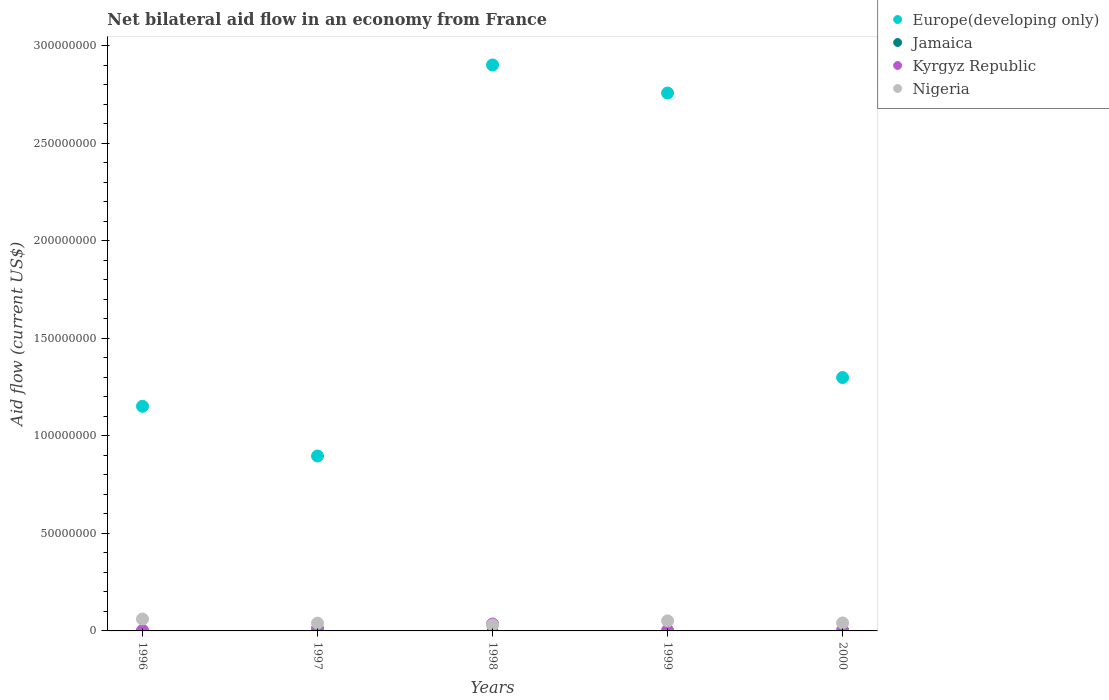Is the number of dotlines equal to the number of legend labels?
Provide a succinct answer. No. What is the net bilateral aid flow in Europe(developing only) in 1999?
Keep it short and to the point. 2.76e+08. Across all years, what is the maximum net bilateral aid flow in Nigeria?
Offer a very short reply. 6.08e+06. Across all years, what is the minimum net bilateral aid flow in Kyrgyz Republic?
Offer a terse response. 2.50e+05. What is the total net bilateral aid flow in Europe(developing only) in the graph?
Your answer should be compact. 9.01e+08. What is the difference between the net bilateral aid flow in Kyrgyz Republic in 1998 and that in 1999?
Your answer should be compact. 3.26e+06. What is the difference between the net bilateral aid flow in Kyrgyz Republic in 1997 and the net bilateral aid flow in Nigeria in 2000?
Provide a short and direct response. -2.86e+06. What is the average net bilateral aid flow in Europe(developing only) per year?
Keep it short and to the point. 1.80e+08. In the year 1996, what is the difference between the net bilateral aid flow in Nigeria and net bilateral aid flow in Europe(developing only)?
Provide a succinct answer. -1.09e+08. In how many years, is the net bilateral aid flow in Nigeria greater than 180000000 US$?
Your response must be concise. 0. What is the ratio of the net bilateral aid flow in Nigeria in 1996 to that in 2000?
Make the answer very short. 1.48. Is the difference between the net bilateral aid flow in Nigeria in 1997 and 1999 greater than the difference between the net bilateral aid flow in Europe(developing only) in 1997 and 1999?
Keep it short and to the point. Yes. What is the difference between the highest and the second highest net bilateral aid flow in Europe(developing only)?
Provide a succinct answer. 1.44e+07. What is the difference between the highest and the lowest net bilateral aid flow in Europe(developing only)?
Your answer should be very brief. 2.01e+08. Is the sum of the net bilateral aid flow in Kyrgyz Republic in 1999 and 2000 greater than the maximum net bilateral aid flow in Nigeria across all years?
Give a very brief answer. No. How many years are there in the graph?
Your answer should be very brief. 5. Does the graph contain grids?
Your response must be concise. No. Where does the legend appear in the graph?
Provide a short and direct response. Top right. How many legend labels are there?
Keep it short and to the point. 4. How are the legend labels stacked?
Your response must be concise. Vertical. What is the title of the graph?
Ensure brevity in your answer.  Net bilateral aid flow in an economy from France. What is the label or title of the Y-axis?
Provide a short and direct response. Aid flow (current US$). What is the Aid flow (current US$) in Europe(developing only) in 1996?
Your answer should be very brief. 1.15e+08. What is the Aid flow (current US$) in Jamaica in 1996?
Make the answer very short. 0. What is the Aid flow (current US$) of Kyrgyz Republic in 1996?
Make the answer very short. 2.50e+05. What is the Aid flow (current US$) of Nigeria in 1996?
Offer a terse response. 6.08e+06. What is the Aid flow (current US$) in Europe(developing only) in 1997?
Your answer should be compact. 8.97e+07. What is the Aid flow (current US$) of Jamaica in 1997?
Give a very brief answer. 0. What is the Aid flow (current US$) in Kyrgyz Republic in 1997?
Keep it short and to the point. 1.24e+06. What is the Aid flow (current US$) in Nigeria in 1997?
Your answer should be very brief. 3.98e+06. What is the Aid flow (current US$) in Europe(developing only) in 1998?
Ensure brevity in your answer.  2.90e+08. What is the Aid flow (current US$) of Jamaica in 1998?
Your answer should be compact. 0. What is the Aid flow (current US$) of Kyrgyz Republic in 1998?
Offer a terse response. 3.55e+06. What is the Aid flow (current US$) in Nigeria in 1998?
Offer a terse response. 3.04e+06. What is the Aid flow (current US$) in Europe(developing only) in 1999?
Your answer should be very brief. 2.76e+08. What is the Aid flow (current US$) of Jamaica in 1999?
Your answer should be very brief. 0. What is the Aid flow (current US$) in Kyrgyz Republic in 1999?
Offer a terse response. 2.90e+05. What is the Aid flow (current US$) in Nigeria in 1999?
Ensure brevity in your answer.  5.16e+06. What is the Aid flow (current US$) in Europe(developing only) in 2000?
Provide a succinct answer. 1.30e+08. What is the Aid flow (current US$) of Kyrgyz Republic in 2000?
Provide a short and direct response. 3.90e+05. What is the Aid flow (current US$) in Nigeria in 2000?
Provide a short and direct response. 4.10e+06. Across all years, what is the maximum Aid flow (current US$) of Europe(developing only)?
Provide a short and direct response. 2.90e+08. Across all years, what is the maximum Aid flow (current US$) of Kyrgyz Republic?
Make the answer very short. 3.55e+06. Across all years, what is the maximum Aid flow (current US$) of Nigeria?
Offer a terse response. 6.08e+06. Across all years, what is the minimum Aid flow (current US$) of Europe(developing only)?
Keep it short and to the point. 8.97e+07. Across all years, what is the minimum Aid flow (current US$) in Kyrgyz Republic?
Provide a short and direct response. 2.50e+05. Across all years, what is the minimum Aid flow (current US$) in Nigeria?
Offer a very short reply. 3.04e+06. What is the total Aid flow (current US$) of Europe(developing only) in the graph?
Provide a short and direct response. 9.01e+08. What is the total Aid flow (current US$) in Jamaica in the graph?
Offer a terse response. 0. What is the total Aid flow (current US$) in Kyrgyz Republic in the graph?
Offer a very short reply. 5.72e+06. What is the total Aid flow (current US$) of Nigeria in the graph?
Your answer should be compact. 2.24e+07. What is the difference between the Aid flow (current US$) in Europe(developing only) in 1996 and that in 1997?
Offer a very short reply. 2.55e+07. What is the difference between the Aid flow (current US$) in Kyrgyz Republic in 1996 and that in 1997?
Your response must be concise. -9.90e+05. What is the difference between the Aid flow (current US$) in Nigeria in 1996 and that in 1997?
Offer a terse response. 2.10e+06. What is the difference between the Aid flow (current US$) in Europe(developing only) in 1996 and that in 1998?
Offer a very short reply. -1.75e+08. What is the difference between the Aid flow (current US$) in Kyrgyz Republic in 1996 and that in 1998?
Provide a short and direct response. -3.30e+06. What is the difference between the Aid flow (current US$) in Nigeria in 1996 and that in 1998?
Keep it short and to the point. 3.04e+06. What is the difference between the Aid flow (current US$) of Europe(developing only) in 1996 and that in 1999?
Your answer should be very brief. -1.61e+08. What is the difference between the Aid flow (current US$) in Nigeria in 1996 and that in 1999?
Give a very brief answer. 9.20e+05. What is the difference between the Aid flow (current US$) in Europe(developing only) in 1996 and that in 2000?
Give a very brief answer. -1.47e+07. What is the difference between the Aid flow (current US$) of Kyrgyz Republic in 1996 and that in 2000?
Keep it short and to the point. -1.40e+05. What is the difference between the Aid flow (current US$) of Nigeria in 1996 and that in 2000?
Provide a short and direct response. 1.98e+06. What is the difference between the Aid flow (current US$) of Europe(developing only) in 1997 and that in 1998?
Keep it short and to the point. -2.01e+08. What is the difference between the Aid flow (current US$) in Kyrgyz Republic in 1997 and that in 1998?
Offer a terse response. -2.31e+06. What is the difference between the Aid flow (current US$) in Nigeria in 1997 and that in 1998?
Offer a very short reply. 9.40e+05. What is the difference between the Aid flow (current US$) of Europe(developing only) in 1997 and that in 1999?
Provide a short and direct response. -1.86e+08. What is the difference between the Aid flow (current US$) of Kyrgyz Republic in 1997 and that in 1999?
Keep it short and to the point. 9.50e+05. What is the difference between the Aid flow (current US$) in Nigeria in 1997 and that in 1999?
Your response must be concise. -1.18e+06. What is the difference between the Aid flow (current US$) of Europe(developing only) in 1997 and that in 2000?
Your answer should be very brief. -4.02e+07. What is the difference between the Aid flow (current US$) of Kyrgyz Republic in 1997 and that in 2000?
Your answer should be compact. 8.50e+05. What is the difference between the Aid flow (current US$) of Europe(developing only) in 1998 and that in 1999?
Your response must be concise. 1.44e+07. What is the difference between the Aid flow (current US$) of Kyrgyz Republic in 1998 and that in 1999?
Provide a short and direct response. 3.26e+06. What is the difference between the Aid flow (current US$) of Nigeria in 1998 and that in 1999?
Make the answer very short. -2.12e+06. What is the difference between the Aid flow (current US$) in Europe(developing only) in 1998 and that in 2000?
Your response must be concise. 1.60e+08. What is the difference between the Aid flow (current US$) in Kyrgyz Republic in 1998 and that in 2000?
Ensure brevity in your answer.  3.16e+06. What is the difference between the Aid flow (current US$) of Nigeria in 1998 and that in 2000?
Your answer should be compact. -1.06e+06. What is the difference between the Aid flow (current US$) in Europe(developing only) in 1999 and that in 2000?
Offer a terse response. 1.46e+08. What is the difference between the Aid flow (current US$) of Kyrgyz Republic in 1999 and that in 2000?
Make the answer very short. -1.00e+05. What is the difference between the Aid flow (current US$) in Nigeria in 1999 and that in 2000?
Your answer should be very brief. 1.06e+06. What is the difference between the Aid flow (current US$) of Europe(developing only) in 1996 and the Aid flow (current US$) of Kyrgyz Republic in 1997?
Keep it short and to the point. 1.14e+08. What is the difference between the Aid flow (current US$) in Europe(developing only) in 1996 and the Aid flow (current US$) in Nigeria in 1997?
Offer a very short reply. 1.11e+08. What is the difference between the Aid flow (current US$) in Kyrgyz Republic in 1996 and the Aid flow (current US$) in Nigeria in 1997?
Provide a succinct answer. -3.73e+06. What is the difference between the Aid flow (current US$) in Europe(developing only) in 1996 and the Aid flow (current US$) in Kyrgyz Republic in 1998?
Your response must be concise. 1.12e+08. What is the difference between the Aid flow (current US$) of Europe(developing only) in 1996 and the Aid flow (current US$) of Nigeria in 1998?
Your answer should be very brief. 1.12e+08. What is the difference between the Aid flow (current US$) in Kyrgyz Republic in 1996 and the Aid flow (current US$) in Nigeria in 1998?
Provide a succinct answer. -2.79e+06. What is the difference between the Aid flow (current US$) of Europe(developing only) in 1996 and the Aid flow (current US$) of Kyrgyz Republic in 1999?
Offer a very short reply. 1.15e+08. What is the difference between the Aid flow (current US$) of Europe(developing only) in 1996 and the Aid flow (current US$) of Nigeria in 1999?
Keep it short and to the point. 1.10e+08. What is the difference between the Aid flow (current US$) in Kyrgyz Republic in 1996 and the Aid flow (current US$) in Nigeria in 1999?
Ensure brevity in your answer.  -4.91e+06. What is the difference between the Aid flow (current US$) of Europe(developing only) in 1996 and the Aid flow (current US$) of Kyrgyz Republic in 2000?
Your response must be concise. 1.15e+08. What is the difference between the Aid flow (current US$) in Europe(developing only) in 1996 and the Aid flow (current US$) in Nigeria in 2000?
Provide a succinct answer. 1.11e+08. What is the difference between the Aid flow (current US$) in Kyrgyz Republic in 1996 and the Aid flow (current US$) in Nigeria in 2000?
Provide a short and direct response. -3.85e+06. What is the difference between the Aid flow (current US$) of Europe(developing only) in 1997 and the Aid flow (current US$) of Kyrgyz Republic in 1998?
Offer a terse response. 8.62e+07. What is the difference between the Aid flow (current US$) in Europe(developing only) in 1997 and the Aid flow (current US$) in Nigeria in 1998?
Provide a short and direct response. 8.67e+07. What is the difference between the Aid flow (current US$) in Kyrgyz Republic in 1997 and the Aid flow (current US$) in Nigeria in 1998?
Your answer should be very brief. -1.80e+06. What is the difference between the Aid flow (current US$) of Europe(developing only) in 1997 and the Aid flow (current US$) of Kyrgyz Republic in 1999?
Offer a terse response. 8.94e+07. What is the difference between the Aid flow (current US$) of Europe(developing only) in 1997 and the Aid flow (current US$) of Nigeria in 1999?
Offer a terse response. 8.46e+07. What is the difference between the Aid flow (current US$) in Kyrgyz Republic in 1997 and the Aid flow (current US$) in Nigeria in 1999?
Offer a very short reply. -3.92e+06. What is the difference between the Aid flow (current US$) in Europe(developing only) in 1997 and the Aid flow (current US$) in Kyrgyz Republic in 2000?
Your answer should be very brief. 8.93e+07. What is the difference between the Aid flow (current US$) in Europe(developing only) in 1997 and the Aid flow (current US$) in Nigeria in 2000?
Ensure brevity in your answer.  8.56e+07. What is the difference between the Aid flow (current US$) of Kyrgyz Republic in 1997 and the Aid flow (current US$) of Nigeria in 2000?
Offer a terse response. -2.86e+06. What is the difference between the Aid flow (current US$) of Europe(developing only) in 1998 and the Aid flow (current US$) of Kyrgyz Republic in 1999?
Your answer should be very brief. 2.90e+08. What is the difference between the Aid flow (current US$) of Europe(developing only) in 1998 and the Aid flow (current US$) of Nigeria in 1999?
Your answer should be very brief. 2.85e+08. What is the difference between the Aid flow (current US$) in Kyrgyz Republic in 1998 and the Aid flow (current US$) in Nigeria in 1999?
Your response must be concise. -1.61e+06. What is the difference between the Aid flow (current US$) of Europe(developing only) in 1998 and the Aid flow (current US$) of Kyrgyz Republic in 2000?
Your response must be concise. 2.90e+08. What is the difference between the Aid flow (current US$) of Europe(developing only) in 1998 and the Aid flow (current US$) of Nigeria in 2000?
Give a very brief answer. 2.86e+08. What is the difference between the Aid flow (current US$) of Kyrgyz Republic in 1998 and the Aid flow (current US$) of Nigeria in 2000?
Provide a succinct answer. -5.50e+05. What is the difference between the Aid flow (current US$) in Europe(developing only) in 1999 and the Aid flow (current US$) in Kyrgyz Republic in 2000?
Give a very brief answer. 2.75e+08. What is the difference between the Aid flow (current US$) in Europe(developing only) in 1999 and the Aid flow (current US$) in Nigeria in 2000?
Your answer should be compact. 2.72e+08. What is the difference between the Aid flow (current US$) in Kyrgyz Republic in 1999 and the Aid flow (current US$) in Nigeria in 2000?
Offer a terse response. -3.81e+06. What is the average Aid flow (current US$) in Europe(developing only) per year?
Your answer should be very brief. 1.80e+08. What is the average Aid flow (current US$) in Kyrgyz Republic per year?
Offer a very short reply. 1.14e+06. What is the average Aid flow (current US$) in Nigeria per year?
Your answer should be compact. 4.47e+06. In the year 1996, what is the difference between the Aid flow (current US$) in Europe(developing only) and Aid flow (current US$) in Kyrgyz Republic?
Offer a very short reply. 1.15e+08. In the year 1996, what is the difference between the Aid flow (current US$) in Europe(developing only) and Aid flow (current US$) in Nigeria?
Make the answer very short. 1.09e+08. In the year 1996, what is the difference between the Aid flow (current US$) in Kyrgyz Republic and Aid flow (current US$) in Nigeria?
Offer a terse response. -5.83e+06. In the year 1997, what is the difference between the Aid flow (current US$) of Europe(developing only) and Aid flow (current US$) of Kyrgyz Republic?
Your answer should be compact. 8.85e+07. In the year 1997, what is the difference between the Aid flow (current US$) in Europe(developing only) and Aid flow (current US$) in Nigeria?
Your response must be concise. 8.57e+07. In the year 1997, what is the difference between the Aid flow (current US$) in Kyrgyz Republic and Aid flow (current US$) in Nigeria?
Keep it short and to the point. -2.74e+06. In the year 1998, what is the difference between the Aid flow (current US$) of Europe(developing only) and Aid flow (current US$) of Kyrgyz Republic?
Offer a terse response. 2.87e+08. In the year 1998, what is the difference between the Aid flow (current US$) in Europe(developing only) and Aid flow (current US$) in Nigeria?
Offer a terse response. 2.87e+08. In the year 1998, what is the difference between the Aid flow (current US$) in Kyrgyz Republic and Aid flow (current US$) in Nigeria?
Offer a very short reply. 5.10e+05. In the year 1999, what is the difference between the Aid flow (current US$) in Europe(developing only) and Aid flow (current US$) in Kyrgyz Republic?
Give a very brief answer. 2.76e+08. In the year 1999, what is the difference between the Aid flow (current US$) in Europe(developing only) and Aid flow (current US$) in Nigeria?
Offer a terse response. 2.71e+08. In the year 1999, what is the difference between the Aid flow (current US$) in Kyrgyz Republic and Aid flow (current US$) in Nigeria?
Your answer should be compact. -4.87e+06. In the year 2000, what is the difference between the Aid flow (current US$) in Europe(developing only) and Aid flow (current US$) in Kyrgyz Republic?
Your response must be concise. 1.30e+08. In the year 2000, what is the difference between the Aid flow (current US$) in Europe(developing only) and Aid flow (current US$) in Nigeria?
Offer a very short reply. 1.26e+08. In the year 2000, what is the difference between the Aid flow (current US$) of Kyrgyz Republic and Aid flow (current US$) of Nigeria?
Ensure brevity in your answer.  -3.71e+06. What is the ratio of the Aid flow (current US$) in Europe(developing only) in 1996 to that in 1997?
Make the answer very short. 1.28. What is the ratio of the Aid flow (current US$) in Kyrgyz Republic in 1996 to that in 1997?
Provide a short and direct response. 0.2. What is the ratio of the Aid flow (current US$) in Nigeria in 1996 to that in 1997?
Offer a very short reply. 1.53. What is the ratio of the Aid flow (current US$) of Europe(developing only) in 1996 to that in 1998?
Give a very brief answer. 0.4. What is the ratio of the Aid flow (current US$) of Kyrgyz Republic in 1996 to that in 1998?
Give a very brief answer. 0.07. What is the ratio of the Aid flow (current US$) of Nigeria in 1996 to that in 1998?
Ensure brevity in your answer.  2. What is the ratio of the Aid flow (current US$) of Europe(developing only) in 1996 to that in 1999?
Keep it short and to the point. 0.42. What is the ratio of the Aid flow (current US$) of Kyrgyz Republic in 1996 to that in 1999?
Offer a very short reply. 0.86. What is the ratio of the Aid flow (current US$) of Nigeria in 1996 to that in 1999?
Your answer should be very brief. 1.18. What is the ratio of the Aid flow (current US$) of Europe(developing only) in 1996 to that in 2000?
Provide a succinct answer. 0.89. What is the ratio of the Aid flow (current US$) of Kyrgyz Republic in 1996 to that in 2000?
Make the answer very short. 0.64. What is the ratio of the Aid flow (current US$) in Nigeria in 1996 to that in 2000?
Keep it short and to the point. 1.48. What is the ratio of the Aid flow (current US$) in Europe(developing only) in 1997 to that in 1998?
Provide a succinct answer. 0.31. What is the ratio of the Aid flow (current US$) of Kyrgyz Republic in 1997 to that in 1998?
Ensure brevity in your answer.  0.35. What is the ratio of the Aid flow (current US$) of Nigeria in 1997 to that in 1998?
Make the answer very short. 1.31. What is the ratio of the Aid flow (current US$) of Europe(developing only) in 1997 to that in 1999?
Provide a succinct answer. 0.33. What is the ratio of the Aid flow (current US$) in Kyrgyz Republic in 1997 to that in 1999?
Provide a succinct answer. 4.28. What is the ratio of the Aid flow (current US$) of Nigeria in 1997 to that in 1999?
Your response must be concise. 0.77. What is the ratio of the Aid flow (current US$) of Europe(developing only) in 1997 to that in 2000?
Give a very brief answer. 0.69. What is the ratio of the Aid flow (current US$) in Kyrgyz Republic in 1997 to that in 2000?
Provide a short and direct response. 3.18. What is the ratio of the Aid flow (current US$) of Nigeria in 1997 to that in 2000?
Provide a short and direct response. 0.97. What is the ratio of the Aid flow (current US$) in Europe(developing only) in 1998 to that in 1999?
Your answer should be very brief. 1.05. What is the ratio of the Aid flow (current US$) of Kyrgyz Republic in 1998 to that in 1999?
Ensure brevity in your answer.  12.24. What is the ratio of the Aid flow (current US$) in Nigeria in 1998 to that in 1999?
Keep it short and to the point. 0.59. What is the ratio of the Aid flow (current US$) in Europe(developing only) in 1998 to that in 2000?
Your answer should be very brief. 2.23. What is the ratio of the Aid flow (current US$) in Kyrgyz Republic in 1998 to that in 2000?
Your answer should be very brief. 9.1. What is the ratio of the Aid flow (current US$) in Nigeria in 1998 to that in 2000?
Your answer should be compact. 0.74. What is the ratio of the Aid flow (current US$) in Europe(developing only) in 1999 to that in 2000?
Give a very brief answer. 2.12. What is the ratio of the Aid flow (current US$) in Kyrgyz Republic in 1999 to that in 2000?
Keep it short and to the point. 0.74. What is the ratio of the Aid flow (current US$) of Nigeria in 1999 to that in 2000?
Provide a short and direct response. 1.26. What is the difference between the highest and the second highest Aid flow (current US$) in Europe(developing only)?
Offer a very short reply. 1.44e+07. What is the difference between the highest and the second highest Aid flow (current US$) in Kyrgyz Republic?
Provide a short and direct response. 2.31e+06. What is the difference between the highest and the second highest Aid flow (current US$) in Nigeria?
Your response must be concise. 9.20e+05. What is the difference between the highest and the lowest Aid flow (current US$) in Europe(developing only)?
Make the answer very short. 2.01e+08. What is the difference between the highest and the lowest Aid flow (current US$) of Kyrgyz Republic?
Offer a terse response. 3.30e+06. What is the difference between the highest and the lowest Aid flow (current US$) of Nigeria?
Keep it short and to the point. 3.04e+06. 